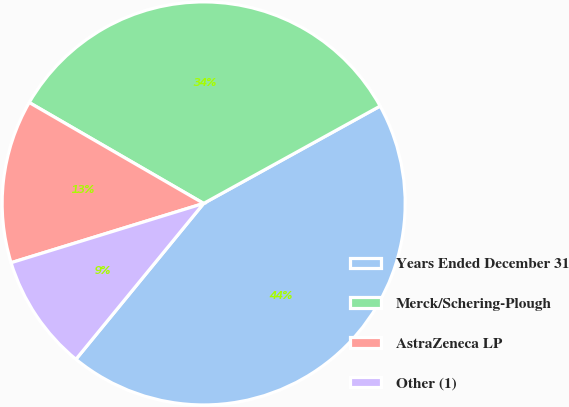Convert chart. <chart><loc_0><loc_0><loc_500><loc_500><pie_chart><fcel>Years Ended December 31<fcel>Merck/Schering-Plough<fcel>AstraZeneca LP<fcel>Other (1)<nl><fcel>43.95%<fcel>33.63%<fcel>13.1%<fcel>9.32%<nl></chart> 